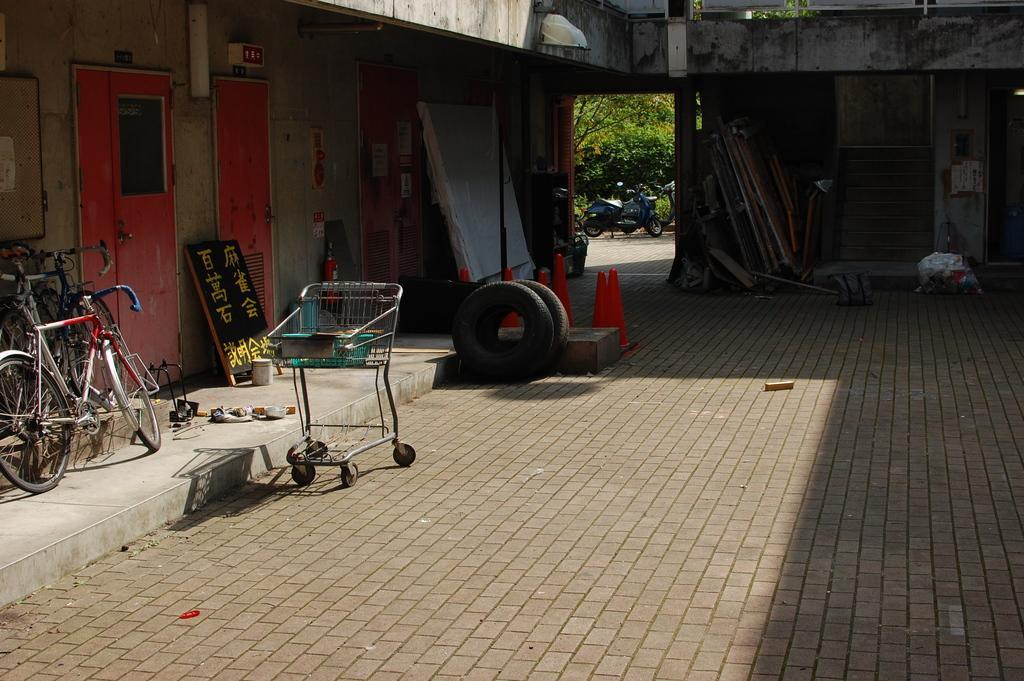How would you summarize this image in a sentence or two? In this image I can see the bicycles, boards, trolley, tires, traffic cones, fire extinguisher and many wooden objects. I can see some boards and doors to the wall. In the background I can see the motorbikes and many trees. 